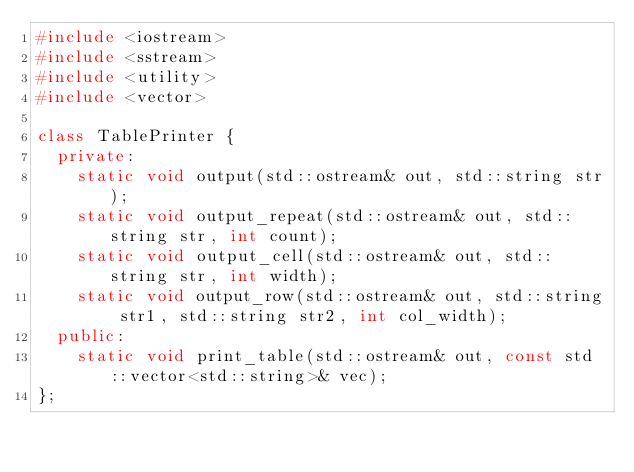Convert code to text. <code><loc_0><loc_0><loc_500><loc_500><_C++_>#include <iostream>
#include <sstream>
#include <utility>
#include <vector>

class TablePrinter {
  private:
    static void output(std::ostream& out, std::string str);
    static void output_repeat(std::ostream& out, std::string str, int count);
    static void output_cell(std::ostream& out, std::string str, int width);
    static void output_row(std::ostream& out, std::string str1, std::string str2, int col_width);
  public:
    static void print_table(std::ostream& out, const std::vector<std::string>& vec);
};
</code> 